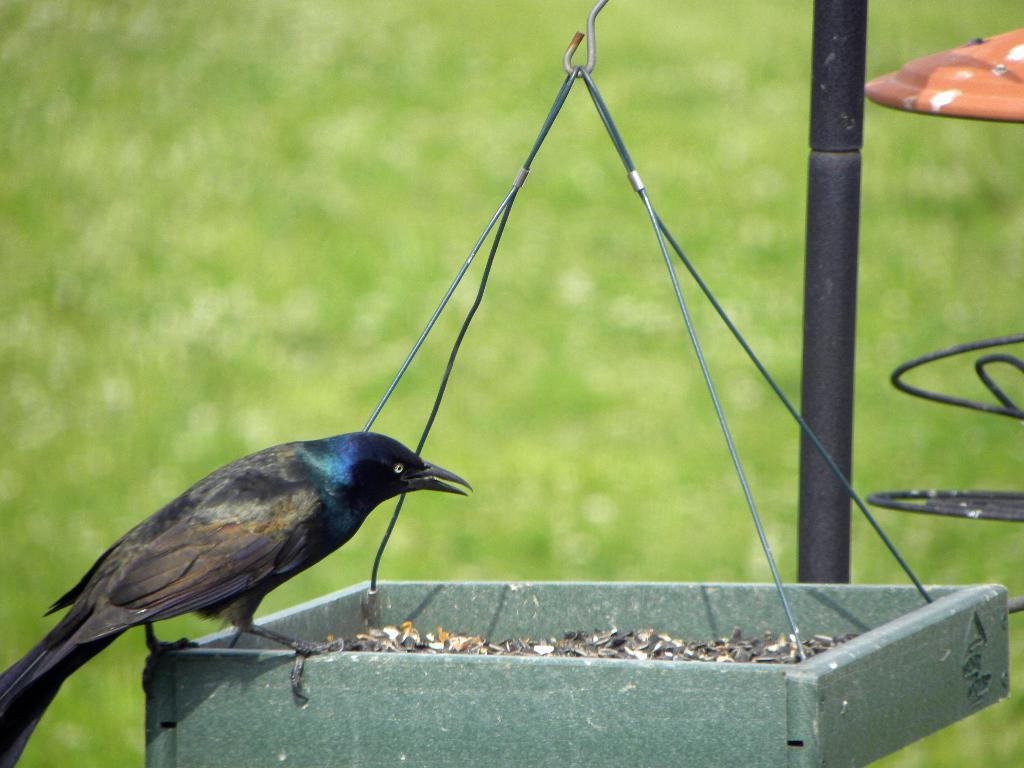What type of bird can be seen in the picture? There is a crow in the picture. What object is hanging in the picture? There is a wooden basket hanging in the picture. What can be seen on the right side of the picture? There is a stand on the right side of the picture. What type of vegetation is visible on the ground in the picture? Grass is visible on the ground in the picture. How many pizzas are being served on the voyage in the image? There is no reference to a voyage or pizzas in the image; it features a crow, a wooden basket, a stand, and grass on the ground. 